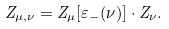<formula> <loc_0><loc_0><loc_500><loc_500>Z _ { \mu , \nu } = Z _ { \mu } [ \varepsilon _ { - } ( \nu ) ] \cdot Z _ { \nu } .</formula> 